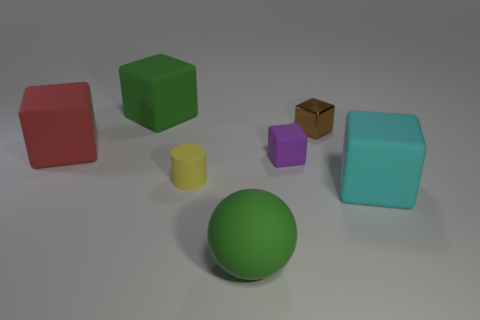Subtract all gray cubes. Subtract all yellow balls. How many cubes are left? 5 Add 3 tiny purple rubber objects. How many objects exist? 10 Subtract all cylinders. How many objects are left? 6 Subtract all large green metallic objects. Subtract all green balls. How many objects are left? 6 Add 3 big red matte blocks. How many big red matte blocks are left? 4 Add 7 big cubes. How many big cubes exist? 10 Subtract 1 purple blocks. How many objects are left? 6 